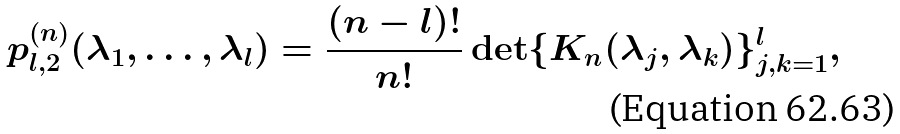Convert formula to latex. <formula><loc_0><loc_0><loc_500><loc_500>p ^ { ( n ) } _ { l , 2 } ( \lambda _ { 1 } , \dots , \lambda _ { l } ) = \frac { ( n - l ) ! } { n ! } \det \{ K _ { n } ( \lambda _ { j } , \lambda _ { k } ) \} _ { j , k = 1 } ^ { l } ,</formula> 